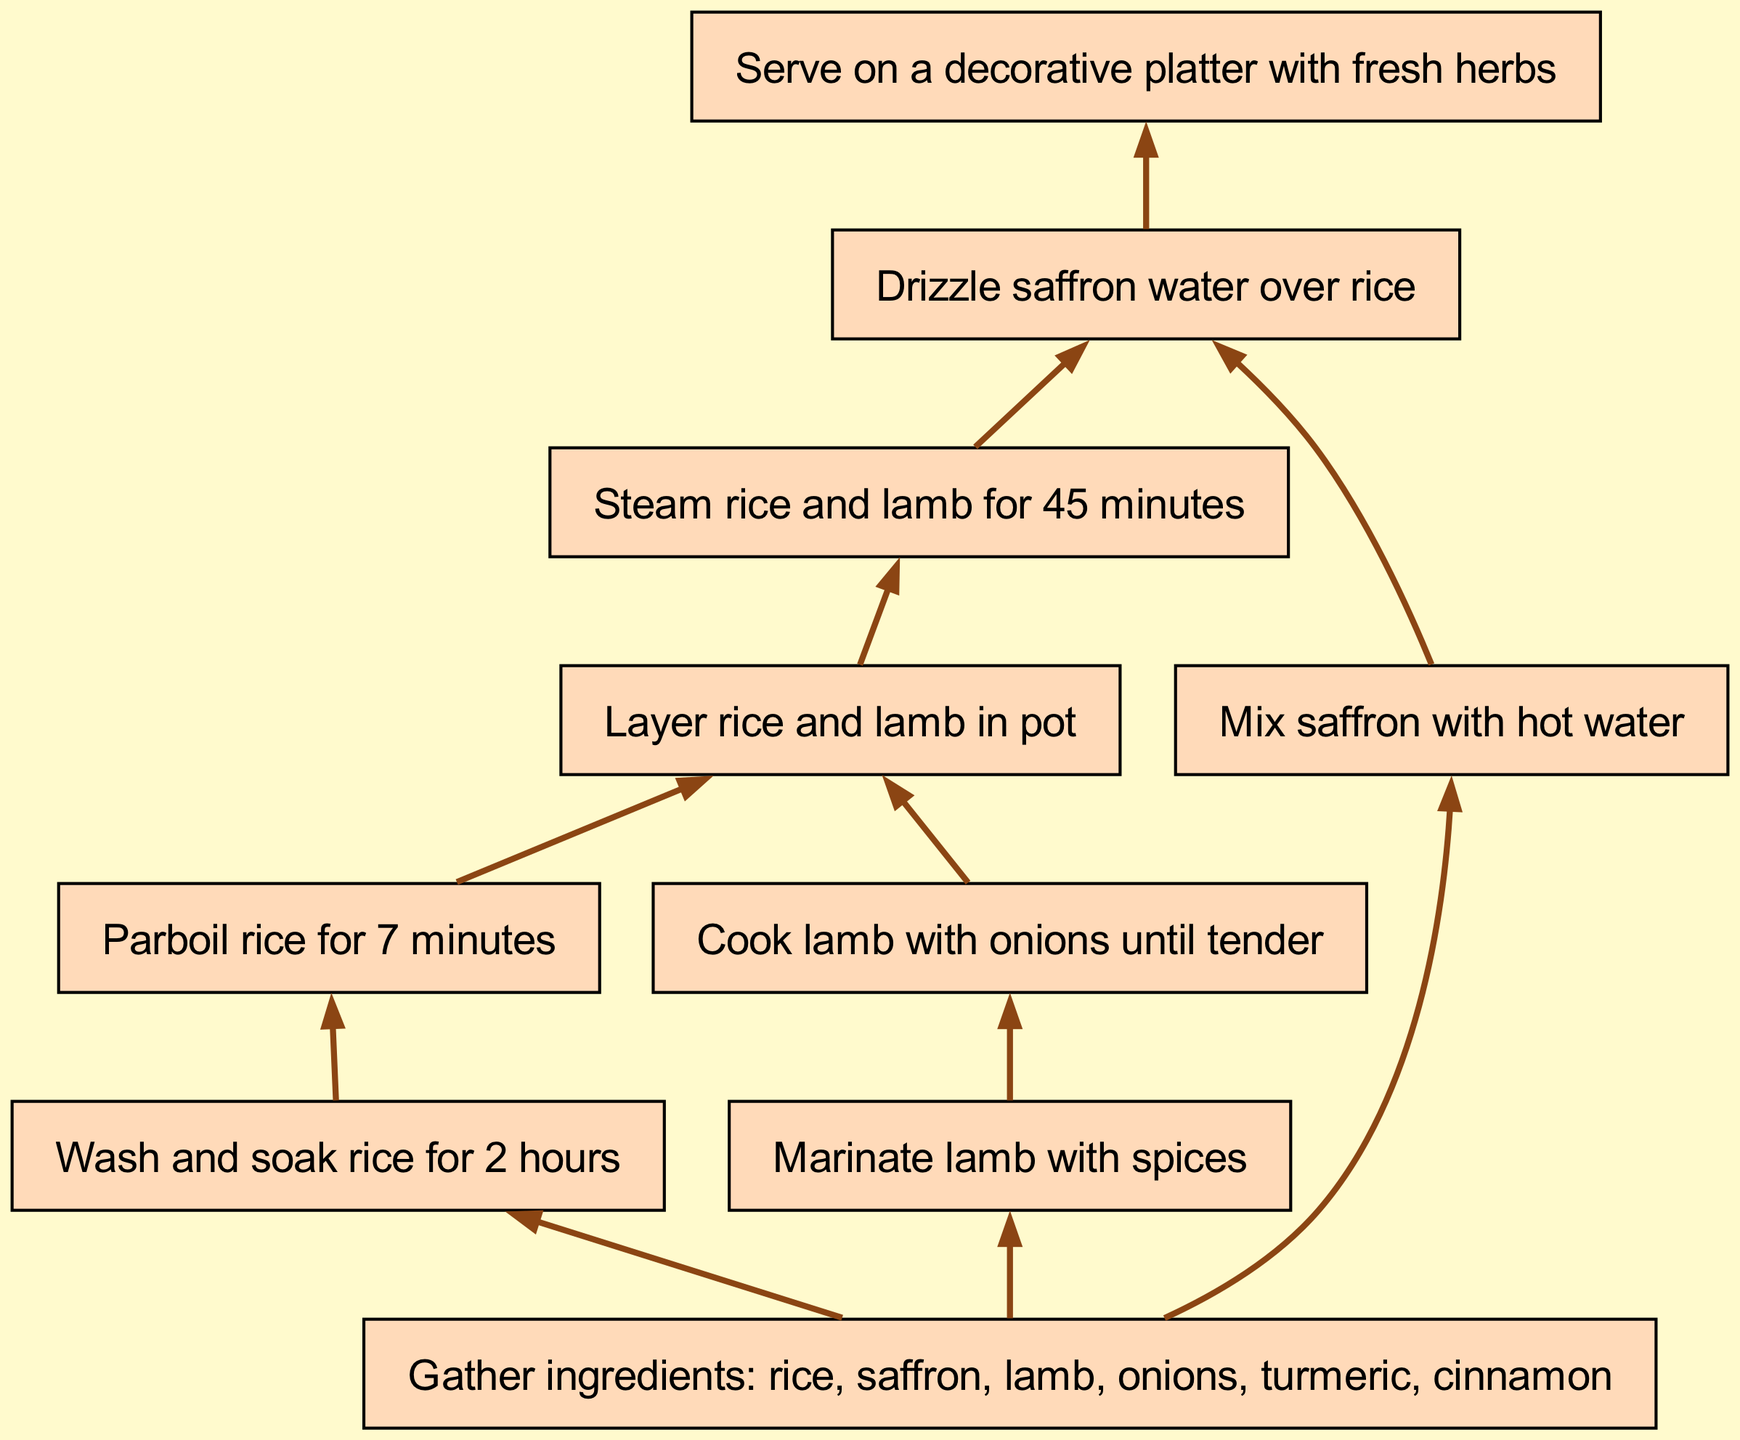What is the first step in the recipe? The first step outlined in the diagram is to "Gather ingredients: rice, saffron, lamb, onions, turmeric, cinnamon." This is the first node in the flow chart, indicating that gathering ingredients is the initial action.
Answer: Gather ingredients: rice, saffron, lamb, onions, turmeric, cinnamon How many main ingredients are listed? The diagram lists six ingredients: rice, saffron, lamb, onions, turmeric, and cinnamon. This count is derived directly from the first node's text in the flow chart.
Answer: Six What requires parboiling after soaking the rice? After washing and soaking the rice for 2 hours, the next step is to "Parboil rice for 7 minutes." This connects the soaking step directly to the parboiling process in the flow.
Answer: Parboil rice Which step comes immediately after marinating the lamb? The step that comes immediately after marinating the lamb with spices is "Cook lamb with onions until tender." This follows the flow from the marinating step directly to the cooking step.
Answer: Cook lamb with onions until tender How long are the rice and lamb steamed together? The diagram states that the rice and lamb are steamed for 45 minutes, which is indicated in the step before the final presentation. This information is derived from the corresponding node in the flow chart.
Answer: 45 minutes What is added over the rice after it's cooked? After the rice has been steamed with the lamb, "Drizzle saffron water over rice" is the next action, indicating that saffron water is added at this stage for flavor.
Answer: Saffron water What happens immediately after the lamb is cooked? The immediate action after cooking the lamb with onions until tender is to "Layer rice and lamb in pot." This transition reflects the preparation for the final cooking stage.
Answer: Layer rice and lamb in pot Where does the final presentation of the dish occur? The dish is served "on a decorative platter with fresh herbs," which is the last step in the sequence of actions leading to the final presentation of the dish.
Answer: On a decorative platter with fresh herbs How many connections are present in the diagram? The diagram includes ten connections that link the various steps together in a flowing manner, indicating the sequence of actions. This count can be confirmed by examining the connections listed in the diagram.
Answer: Ten 